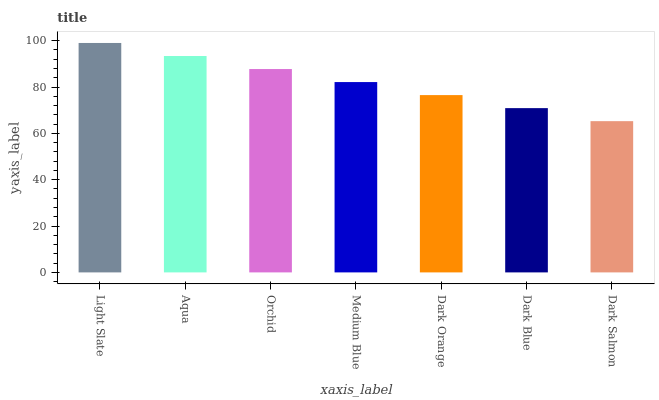Is Aqua the minimum?
Answer yes or no. No. Is Aqua the maximum?
Answer yes or no. No. Is Light Slate greater than Aqua?
Answer yes or no. Yes. Is Aqua less than Light Slate?
Answer yes or no. Yes. Is Aqua greater than Light Slate?
Answer yes or no. No. Is Light Slate less than Aqua?
Answer yes or no. No. Is Medium Blue the high median?
Answer yes or no. Yes. Is Medium Blue the low median?
Answer yes or no. Yes. Is Dark Salmon the high median?
Answer yes or no. No. Is Dark Blue the low median?
Answer yes or no. No. 